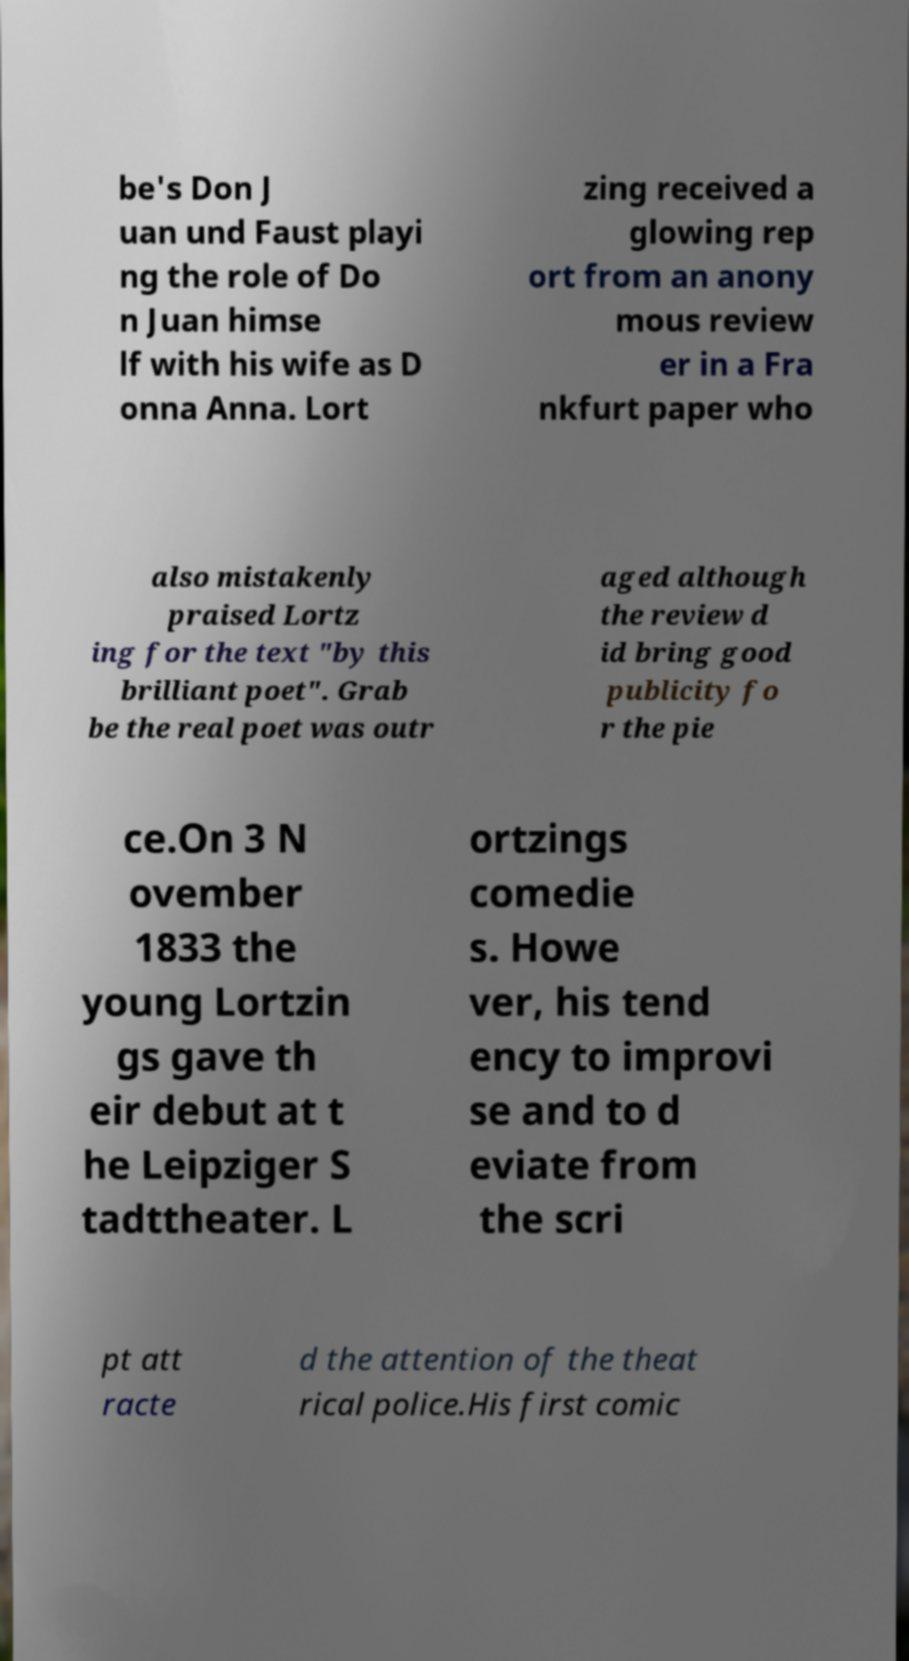Can you read and provide the text displayed in the image?This photo seems to have some interesting text. Can you extract and type it out for me? be's Don J uan und Faust playi ng the role of Do n Juan himse lf with his wife as D onna Anna. Lort zing received a glowing rep ort from an anony mous review er in a Fra nkfurt paper who also mistakenly praised Lortz ing for the text "by this brilliant poet". Grab be the real poet was outr aged although the review d id bring good publicity fo r the pie ce.On 3 N ovember 1833 the young Lortzin gs gave th eir debut at t he Leipziger S tadttheater. L ortzings comedie s. Howe ver, his tend ency to improvi se and to d eviate from the scri pt att racte d the attention of the theat rical police.His first comic 